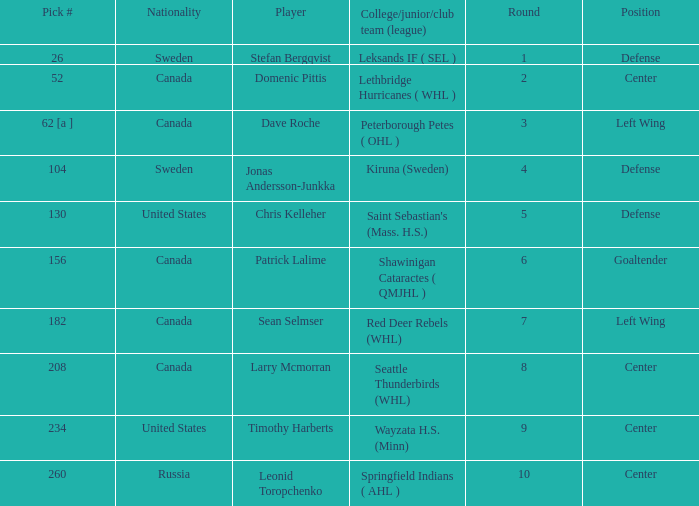What is the college/junior/club team (league) of the player who was pick number 130? Saint Sebastian's (Mass. H.S.). 